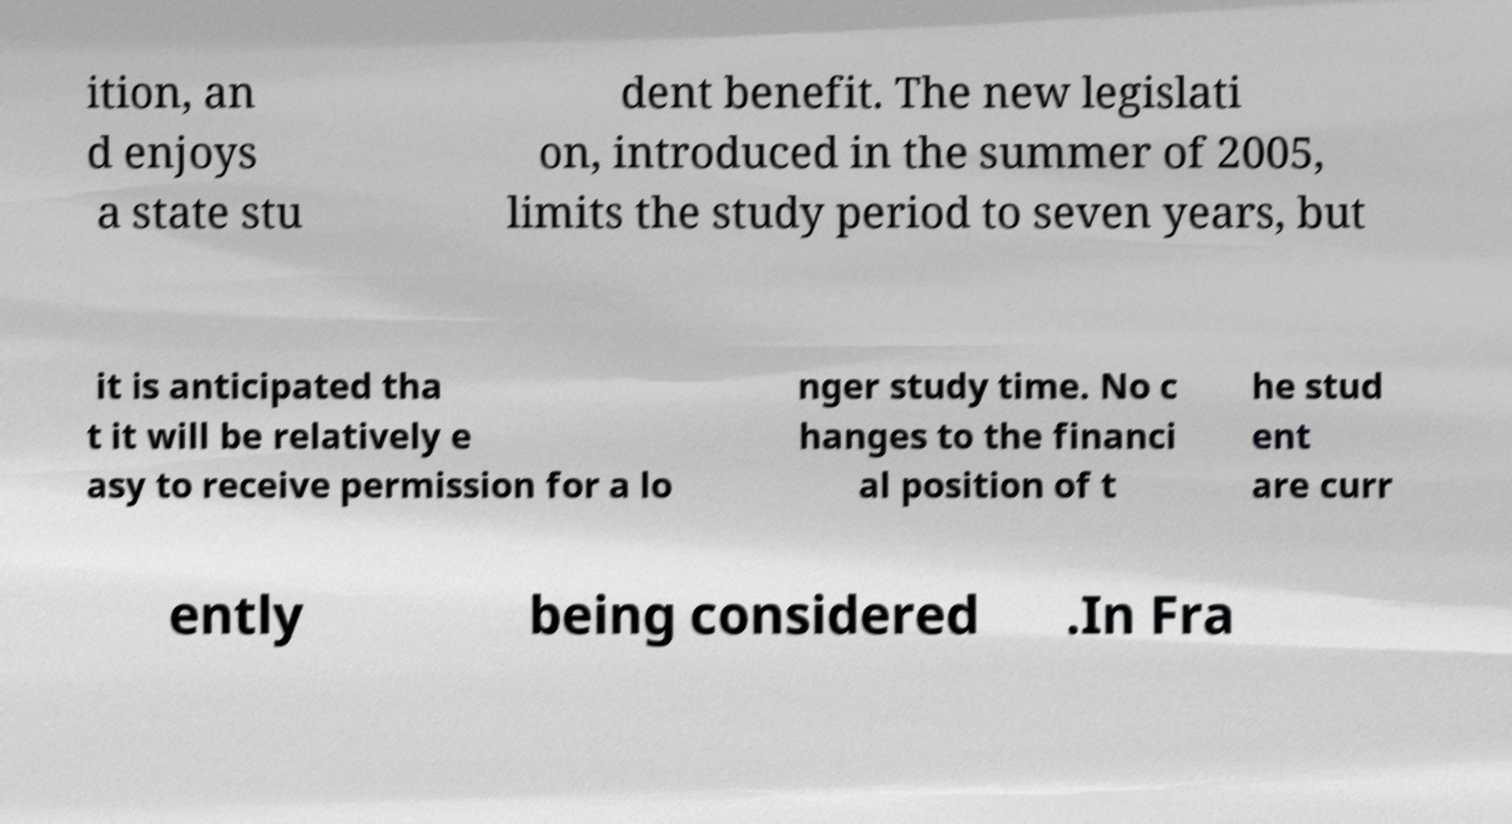There's text embedded in this image that I need extracted. Can you transcribe it verbatim? ition, an d enjoys a state stu dent benefit. The new legislati on, introduced in the summer of 2005, limits the study period to seven years, but it is anticipated tha t it will be relatively e asy to receive permission for a lo nger study time. No c hanges to the financi al position of t he stud ent are curr ently being considered .In Fra 